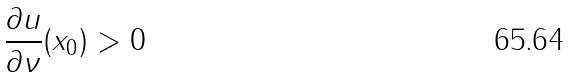<formula> <loc_0><loc_0><loc_500><loc_500>\frac { \partial u } { \partial \nu } ( x _ { 0 } ) > 0</formula> 